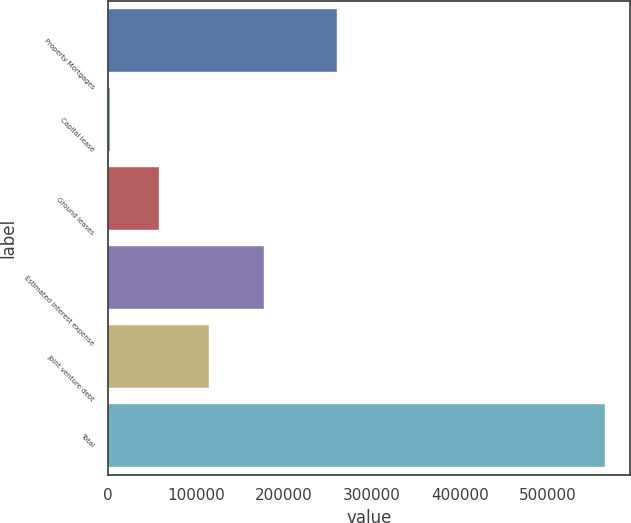Convert chart. <chart><loc_0><loc_0><loc_500><loc_500><bar_chart><fcel>Property Mortgages<fcel>Capital lease<fcel>Ground leases<fcel>Estimated interest expense<fcel>Joint venture debt<fcel>Total<nl><fcel>260433<fcel>1593<fcel>57955<fcel>177565<fcel>114317<fcel>565213<nl></chart> 